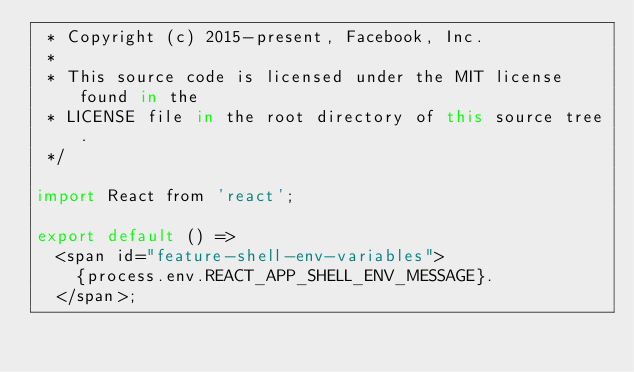<code> <loc_0><loc_0><loc_500><loc_500><_JavaScript_> * Copyright (c) 2015-present, Facebook, Inc.
 *
 * This source code is licensed under the MIT license found in the
 * LICENSE file in the root directory of this source tree.
 */

import React from 'react';

export default () =>
  <span id="feature-shell-env-variables">
    {process.env.REACT_APP_SHELL_ENV_MESSAGE}.
  </span>;
</code> 